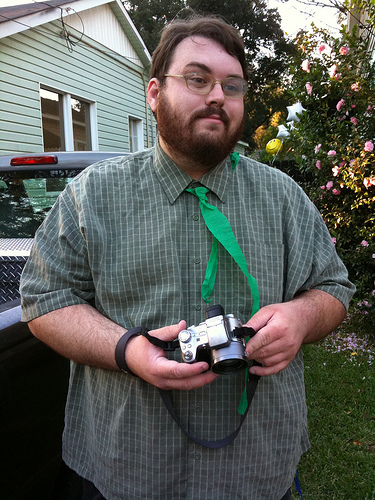What color is the shirt, green or white? The shirt the man is wearing is green with a checkered pattern, rather than white. 